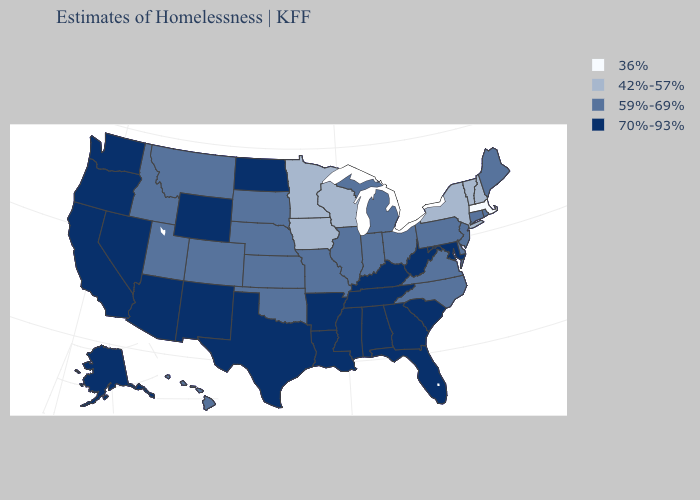Does Wyoming have a higher value than Indiana?
Quick response, please. Yes. Does the map have missing data?
Short answer required. No. Name the states that have a value in the range 42%-57%?
Give a very brief answer. Iowa, Minnesota, New Hampshire, New York, Vermont, Wisconsin. What is the value of Idaho?
Short answer required. 59%-69%. Among the states that border South Carolina , which have the highest value?
Concise answer only. Georgia. What is the value of Oregon?
Give a very brief answer. 70%-93%. What is the value of Rhode Island?
Be succinct. 59%-69%. Does North Dakota have a higher value than Vermont?
Quick response, please. Yes. What is the value of Montana?
Answer briefly. 59%-69%. What is the value of New York?
Be succinct. 42%-57%. Which states have the lowest value in the Northeast?
Give a very brief answer. Massachusetts. Name the states that have a value in the range 42%-57%?
Short answer required. Iowa, Minnesota, New Hampshire, New York, Vermont, Wisconsin. What is the highest value in the West ?
Answer briefly. 70%-93%. Does Massachusetts have the lowest value in the USA?
Keep it brief. Yes. What is the highest value in the South ?
Answer briefly. 70%-93%. 